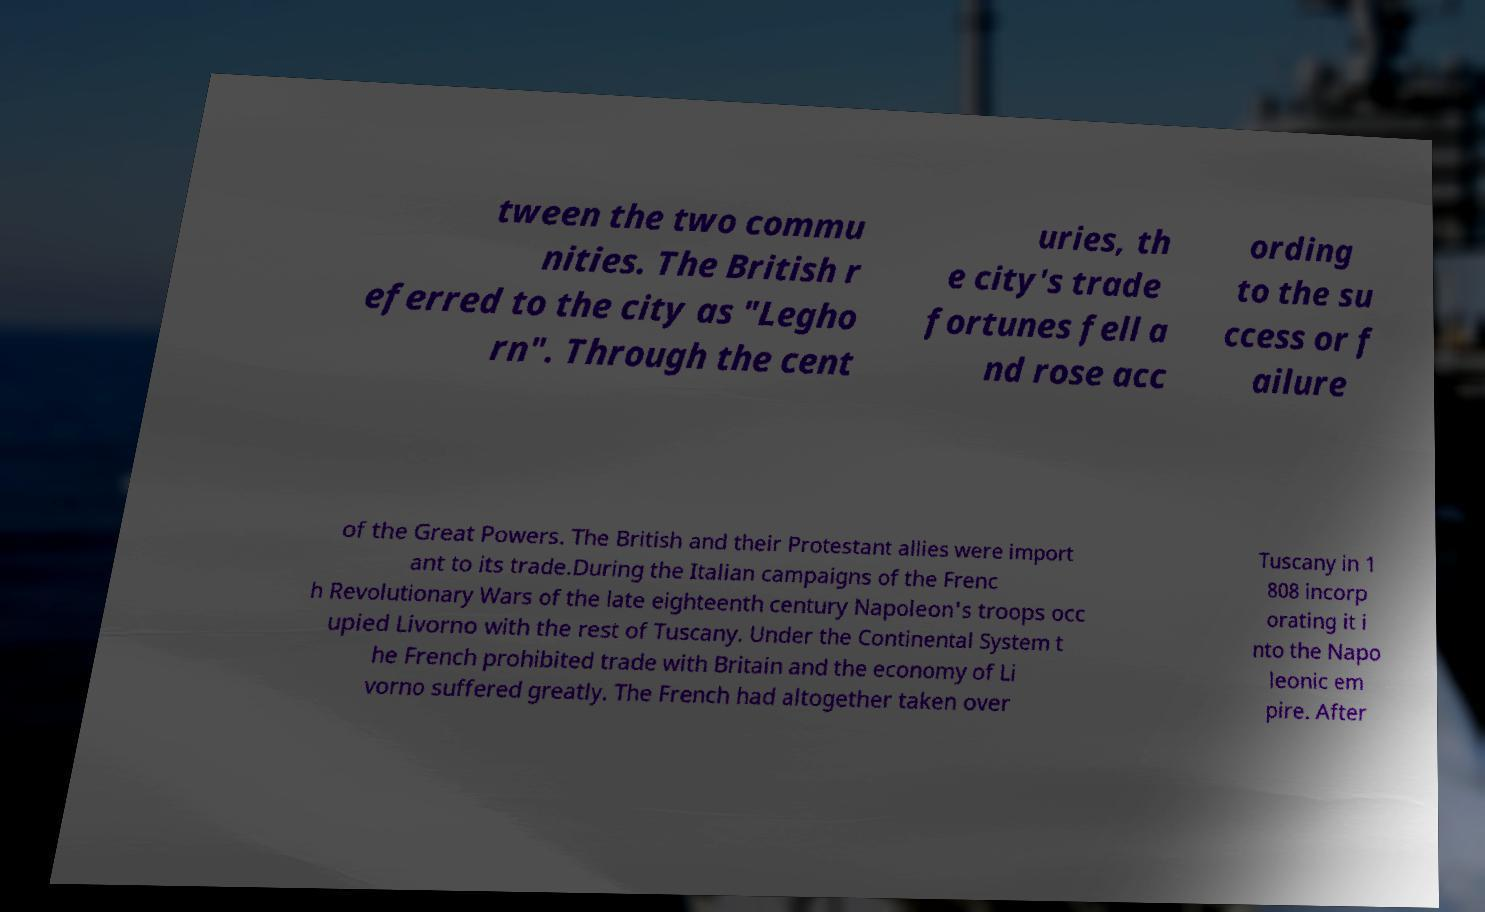Could you assist in decoding the text presented in this image and type it out clearly? tween the two commu nities. The British r eferred to the city as "Legho rn". Through the cent uries, th e city's trade fortunes fell a nd rose acc ording to the su ccess or f ailure of the Great Powers. The British and their Protestant allies were import ant to its trade.During the Italian campaigns of the Frenc h Revolutionary Wars of the late eighteenth century Napoleon's troops occ upied Livorno with the rest of Tuscany. Under the Continental System t he French prohibited trade with Britain and the economy of Li vorno suffered greatly. The French had altogether taken over Tuscany in 1 808 incorp orating it i nto the Napo leonic em pire. After 